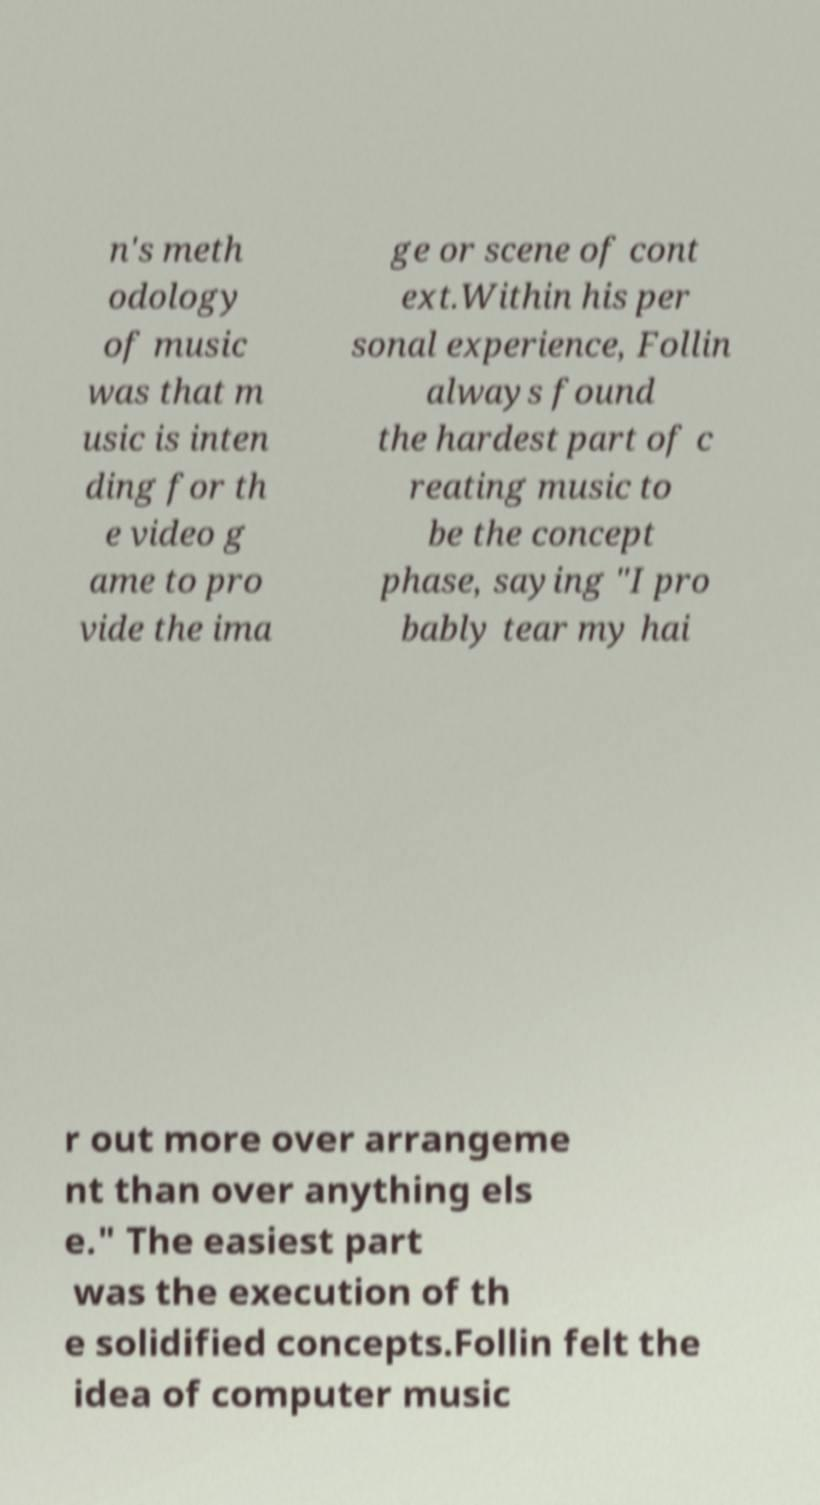Can you read and provide the text displayed in the image?This photo seems to have some interesting text. Can you extract and type it out for me? n's meth odology of music was that m usic is inten ding for th e video g ame to pro vide the ima ge or scene of cont ext.Within his per sonal experience, Follin always found the hardest part of c reating music to be the concept phase, saying "I pro bably tear my hai r out more over arrangeme nt than over anything els e." The easiest part was the execution of th e solidified concepts.Follin felt the idea of computer music 